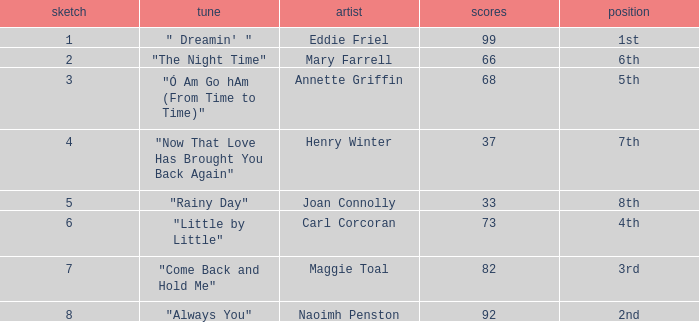What is the average number of points when the ranking is 7th and the draw is less than 4? None. 